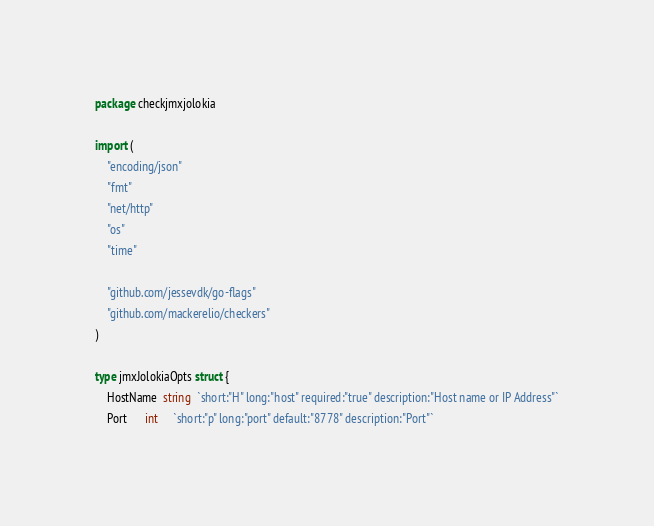<code> <loc_0><loc_0><loc_500><loc_500><_Go_>package checkjmxjolokia

import (
	"encoding/json"
	"fmt"
	"net/http"
	"os"
	"time"

	"github.com/jessevdk/go-flags"
	"github.com/mackerelio/checkers"
)

type jmxJolokiaOpts struct {
	HostName  string  `short:"H" long:"host" required:"true" description:"Host name or IP Address"`
	Port      int     `short:"p" long:"port" default:"8778" description:"Port"`</code> 